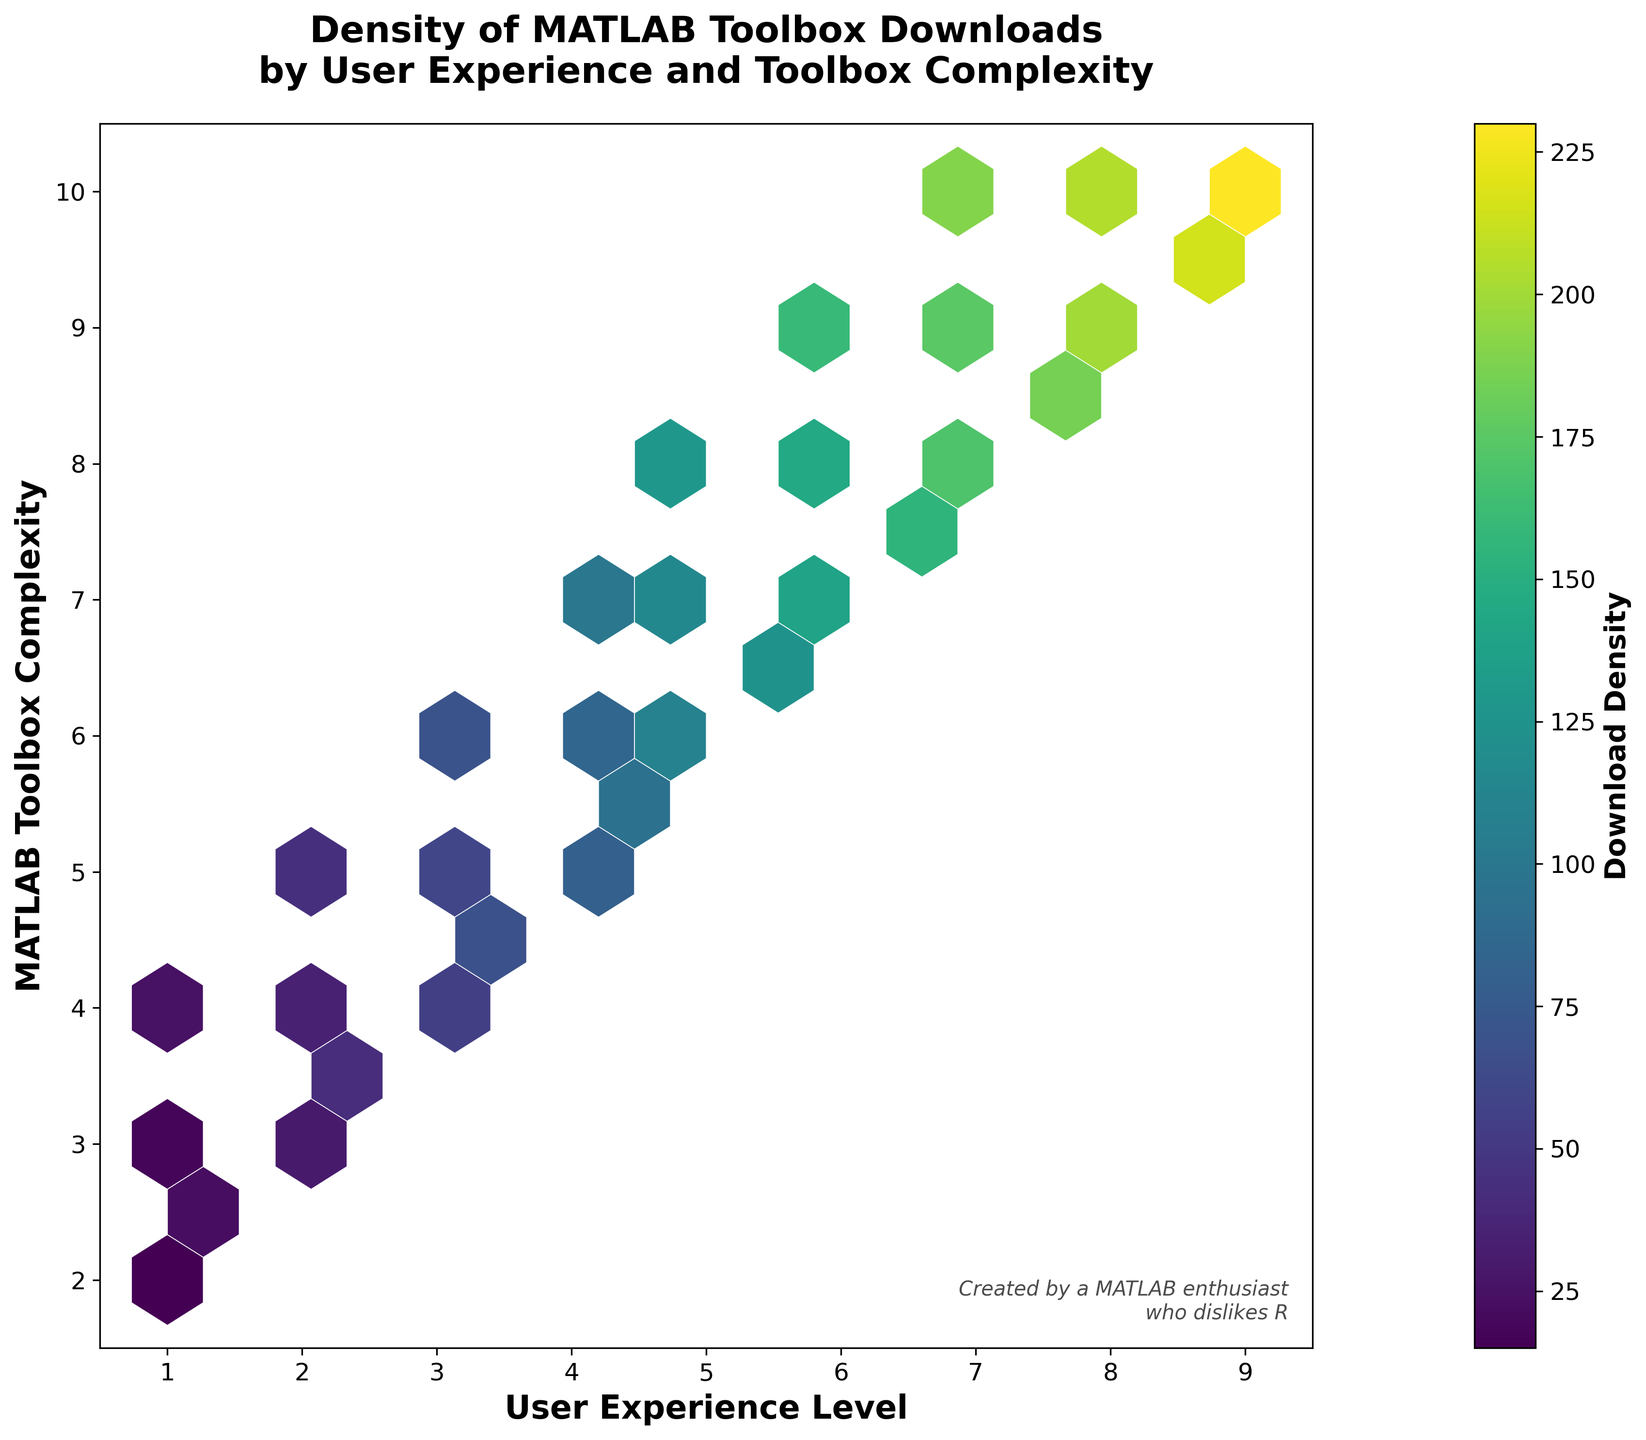What is the color representing the highest density of downloads? The color bar on the right indicates that the highest density is represented by the brightest yellow color in the 'viridis' colormap.
Answer: Yellow What experience level and complexity combination has the highest density of downloads? We see the brightest yellow representing highest density, which occurs at the combination of User Experience Level 9 and MATLAB Toolbox Complexity 10.
Answer: Experience Level 9 and Complexity 10 Which axis represents the MATLAB Toolbox Complexity? The y-axis shows MATLAB Toolbox Complexity as indicated by the label.
Answer: y-axis What is the title of the hexbin plot? The title is written at the top of the plot. It reads "Density of MATLAB Toolbox Downloads by User Experience and Toolbox Complexity".
Answer: Density of MATLAB Toolbox Downloads by User Experience and Toolbox Complexity Are downloads more dense for users with lower experience levels or higher experience levels? By examining the color density (brighter colors), it is clear that higher density patches are towards the higher experience levels (towards the right of the x-axis).
Answer: Higher experience levels What is the range of the y-axis (MATLAB Toolbox Complexity)? Looking at the y-axis, the range spans from 1.5 to 10.5.
Answer: 1.5 to 10.5 Which combinations have a density between 50 and 100 downloads? Referring to the color bar and hexbin plot, combinations around (3, 5), count 60, and (4, 6), count 85, fall within this range.
Answer: (3, 5) and (4, 6) How does the density trend change with increasing user experience levels? The density generally increases as user experience levels increase, as seen in the hexagons becoming brighter yellow towards the right of the plot.
Answer: Increases Compare the download density for users with experience levels of 1 and 9. Users with experience level 9 have significantly higher download density (bright yellow) compared to users with experience level 1 (mostly purple to green).
Answer: Level 9 has higher density What does the text at the bottom-right corner of the plot state? The text at the bottom-right corner of the plot reads "Created by a MATLAB enthusiast who dislikes R".
Answer: Created by a MATLAB enthusiast who dislikes R 